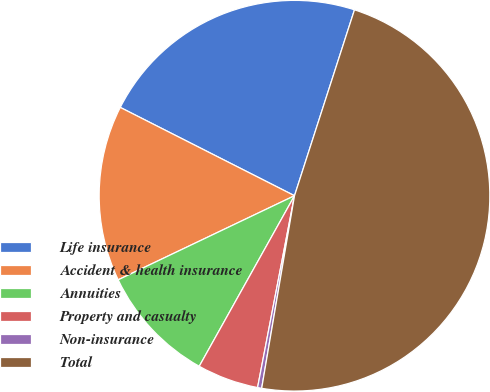Convert chart to OTSL. <chart><loc_0><loc_0><loc_500><loc_500><pie_chart><fcel>Life insurance<fcel>Accident & health insurance<fcel>Annuities<fcel>Property and casualty<fcel>Non-insurance<fcel>Total<nl><fcel>22.5%<fcel>14.55%<fcel>9.81%<fcel>5.08%<fcel>0.34%<fcel>47.72%<nl></chart> 